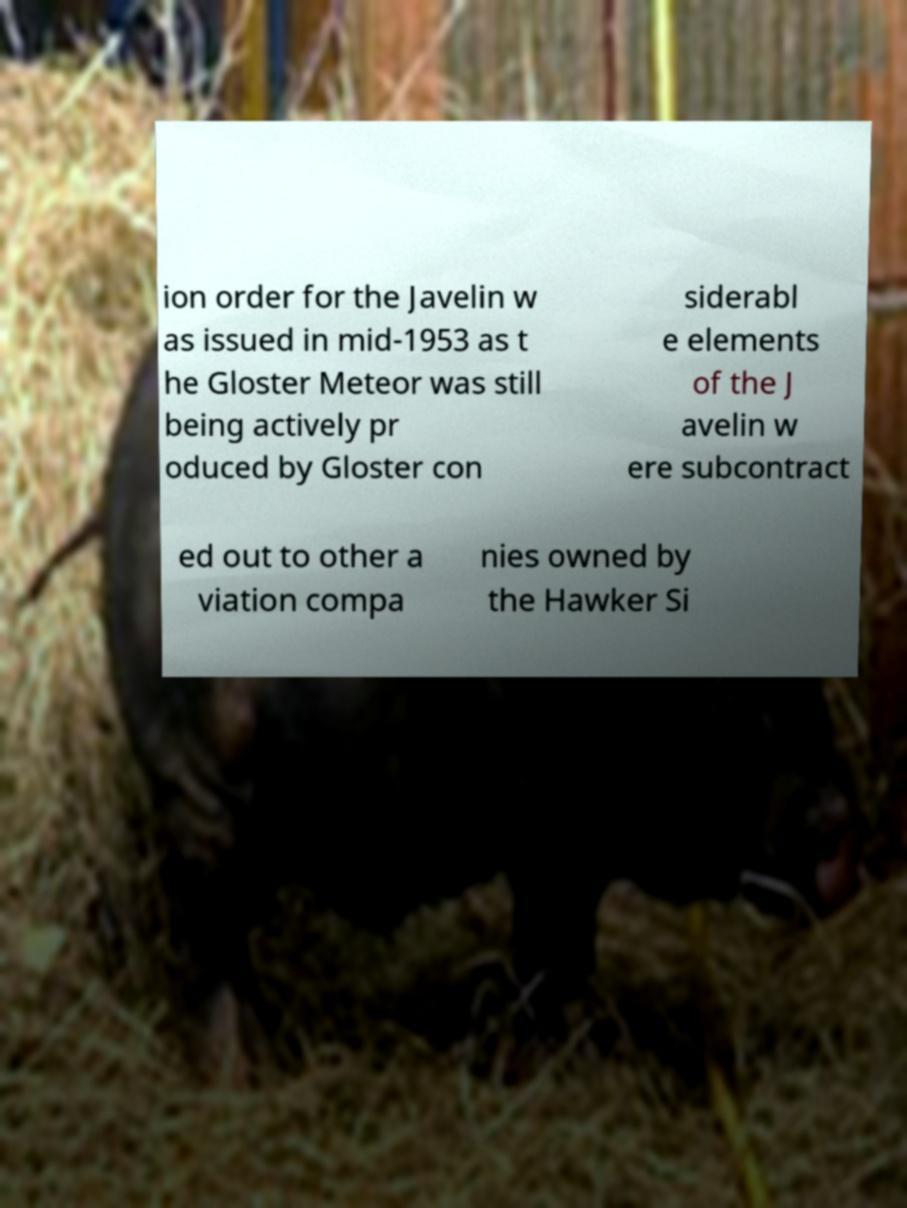Please identify and transcribe the text found in this image. ion order for the Javelin w as issued in mid-1953 as t he Gloster Meteor was still being actively pr oduced by Gloster con siderabl e elements of the J avelin w ere subcontract ed out to other a viation compa nies owned by the Hawker Si 